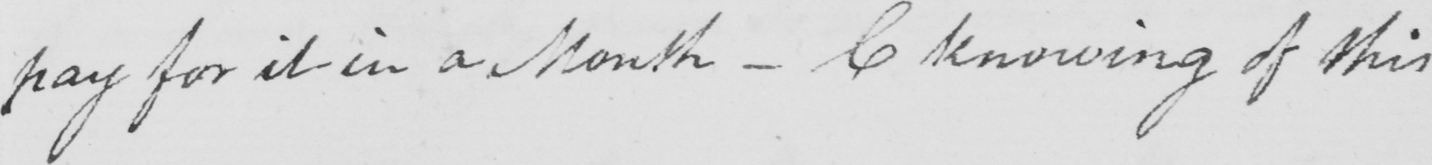Please transcribe the handwritten text in this image. pay for it in a Month _  C knowing of this 